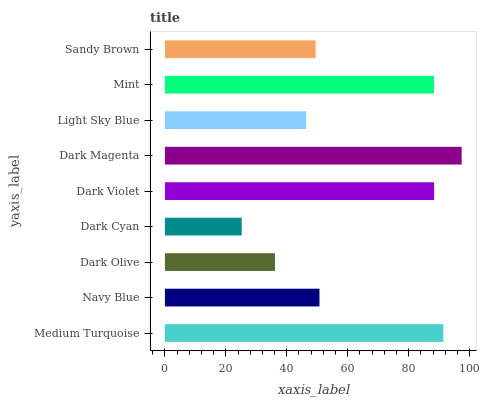Is Dark Cyan the minimum?
Answer yes or no. Yes. Is Dark Magenta the maximum?
Answer yes or no. Yes. Is Navy Blue the minimum?
Answer yes or no. No. Is Navy Blue the maximum?
Answer yes or no. No. Is Medium Turquoise greater than Navy Blue?
Answer yes or no. Yes. Is Navy Blue less than Medium Turquoise?
Answer yes or no. Yes. Is Navy Blue greater than Medium Turquoise?
Answer yes or no. No. Is Medium Turquoise less than Navy Blue?
Answer yes or no. No. Is Navy Blue the high median?
Answer yes or no. Yes. Is Navy Blue the low median?
Answer yes or no. Yes. Is Dark Cyan the high median?
Answer yes or no. No. Is Dark Olive the low median?
Answer yes or no. No. 